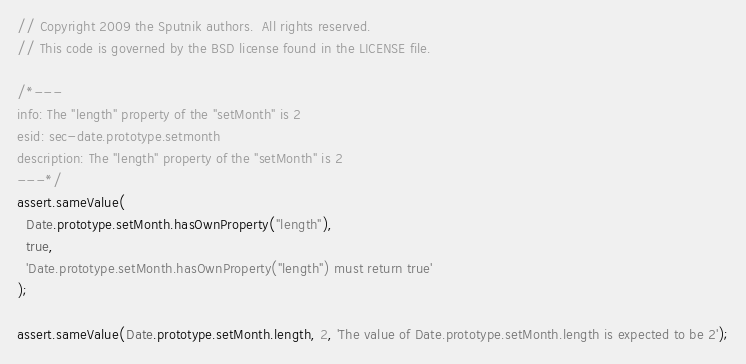<code> <loc_0><loc_0><loc_500><loc_500><_JavaScript_>// Copyright 2009 the Sputnik authors.  All rights reserved.
// This code is governed by the BSD license found in the LICENSE file.

/*---
info: The "length" property of the "setMonth" is 2
esid: sec-date.prototype.setmonth
description: The "length" property of the "setMonth" is 2
---*/
assert.sameValue(
  Date.prototype.setMonth.hasOwnProperty("length"),
  true,
  'Date.prototype.setMonth.hasOwnProperty("length") must return true'
);

assert.sameValue(Date.prototype.setMonth.length, 2, 'The value of Date.prototype.setMonth.length is expected to be 2');
</code> 